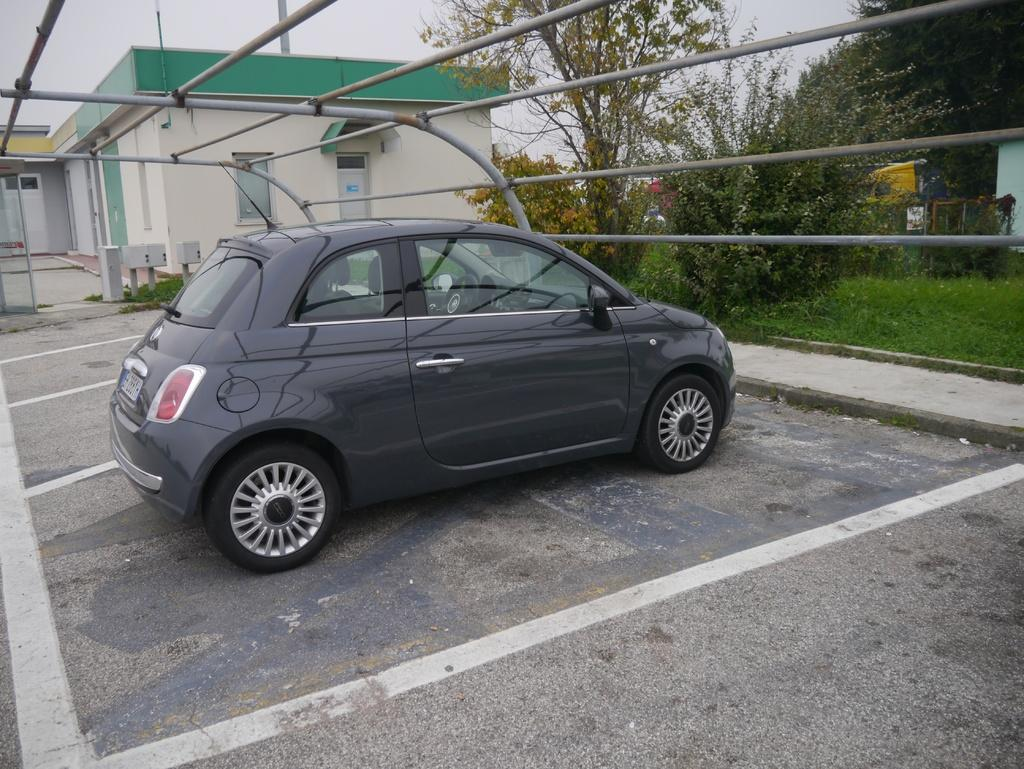What is the main subject of the image? The main subject of the image is a car. Can you describe the car's location in the image? The car is under poles in the image. What else can be seen near the car? There are grills to the side of the car. What other structures are visible in the image? There is a house and trees in the image. Are there any plants in the image? Yes, there are plants in the image. What type of can is placed on the car's hood in the image? There is no can present on the car's hood in the image. What position does the sponge hold in the image? There is no sponge present in the image. 